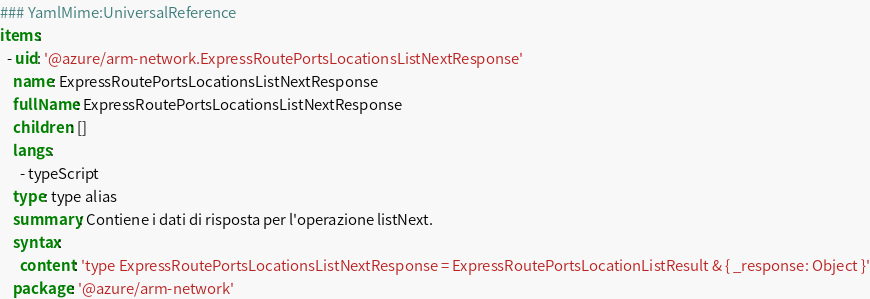Convert code to text. <code><loc_0><loc_0><loc_500><loc_500><_YAML_>### YamlMime:UniversalReference
items:
  - uid: '@azure/arm-network.ExpressRoutePortsLocationsListNextResponse'
    name: ExpressRoutePortsLocationsListNextResponse
    fullName: ExpressRoutePortsLocationsListNextResponse
    children: []
    langs:
      - typeScript
    type: type alias
    summary: Contiene i dati di risposta per l'operazione listNext.
    syntax:
      content: 'type ExpressRoutePortsLocationsListNextResponse = ExpressRoutePortsLocationListResult & { _response: Object }'
    package: '@azure/arm-network'</code> 